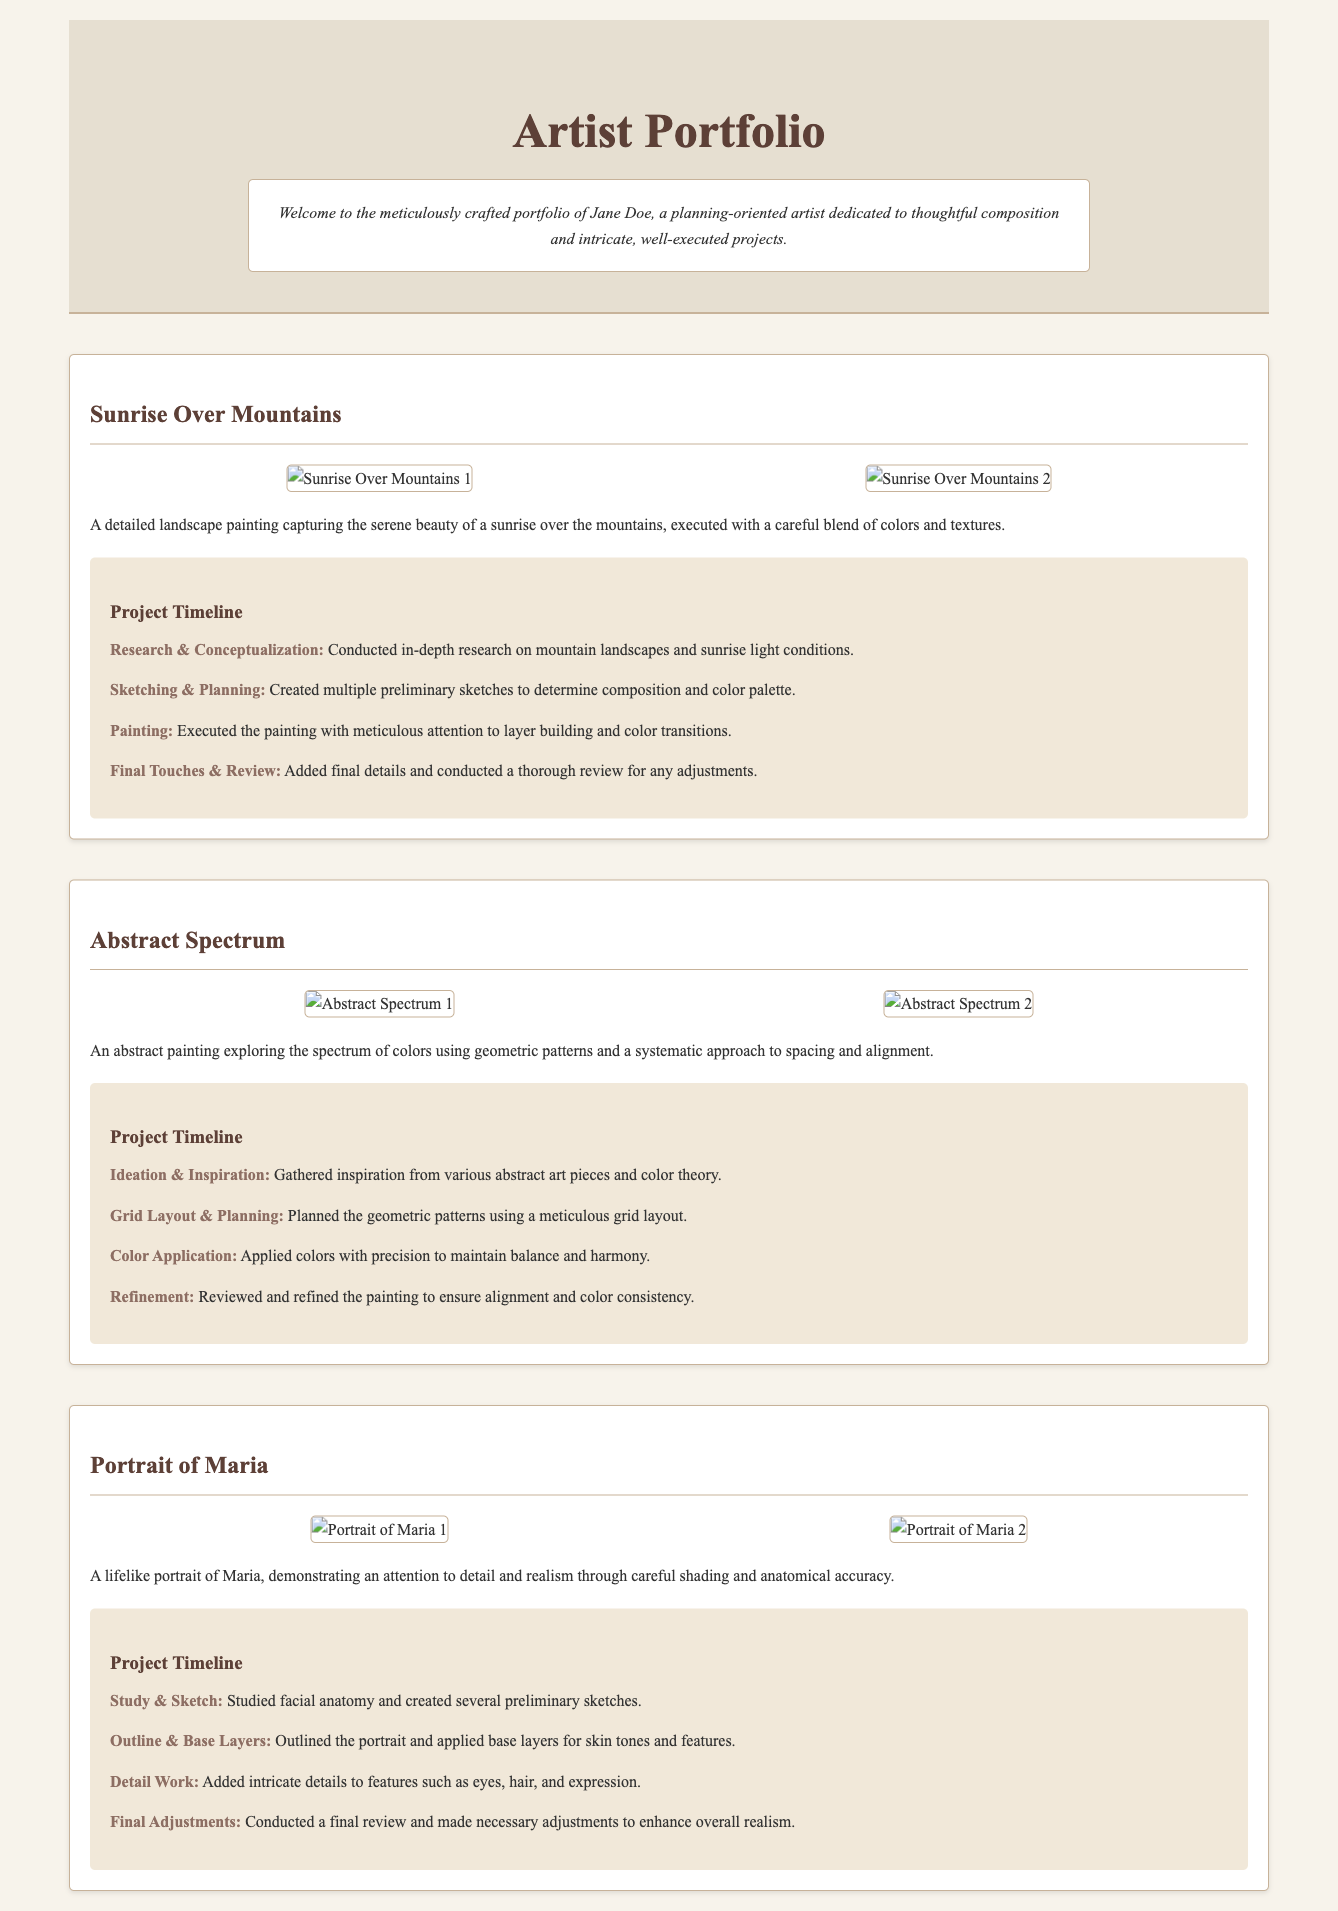What is the name of the artist? The document introduces the artist as Jane Doe in the header section.
Answer: Jane Doe How many projects are showcased in the portfolio? The document presents three distinct projects under the main section.
Answer: Three What is the title of the first project? The first project listed in the document is titled "Sunrise Over Mountains."
Answer: Sunrise Over Mountains What type of painting is "Abstract Spectrum"? The description categorizes "Abstract Spectrum" as an abstract painting.
Answer: Abstract painting What step comes after "Sketching & Planning" in the "Sunrise Over Mountains" timeline? The subsequent step listed after "Sketching & Planning" is "Painting."
Answer: Painting Which painting involves a meticulous grid layout? The timeline for "Abstract Spectrum" indicates the use of a grid layout for planning.
Answer: Abstract Spectrum What aspect of drawing was emphasized for "Portrait of Maria"? The description highlights attention to detail and realism in the portrait.
Answer: Detail and realism How many images are included in the "Sunrise Over Mountains" gallery? The image gallery for this project features two high-resolution images.
Answer: Two What color tone is associated with the final touch in "Portrait of Maria"? The final adjustments for "Portrait of Maria" focus on enhancing overall realism.
Answer: Realism 